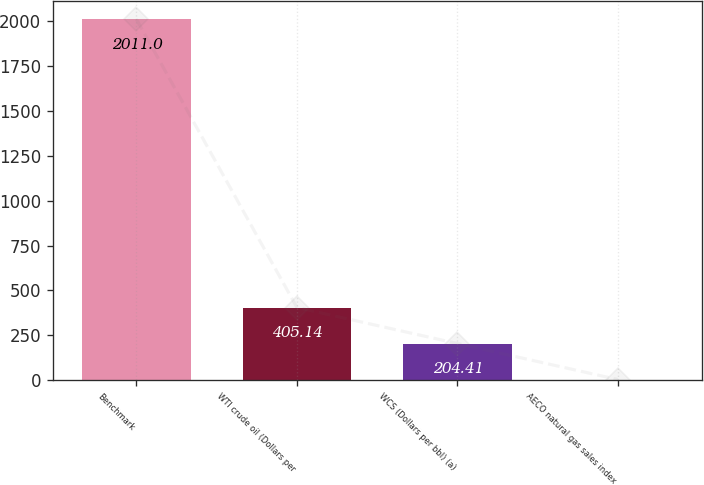Convert chart to OTSL. <chart><loc_0><loc_0><loc_500><loc_500><bar_chart><fcel>Benchmark<fcel>WTI crude oil (Dollars per<fcel>WCS (Dollars per bbl) (a)<fcel>AECO natural gas sales index<nl><fcel>2011<fcel>405.14<fcel>204.41<fcel>3.68<nl></chart> 